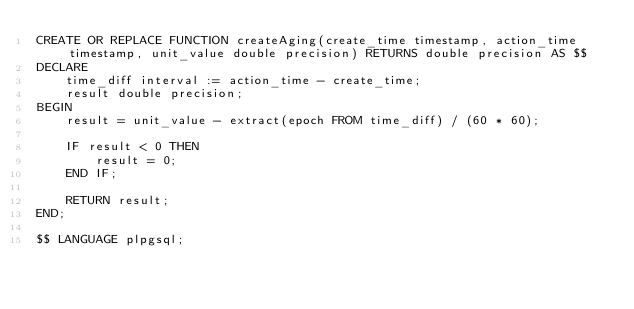Convert code to text. <code><loc_0><loc_0><loc_500><loc_500><_SQL_>CREATE OR REPLACE FUNCTION createAging(create_time timestamp, action_time timestamp, unit_value double precision) RETURNS double precision AS $$
DECLARE
    time_diff interval := action_time - create_time;
    result double precision;
BEGIN
    result = unit_value - extract(epoch FROM time_diff) / (60 * 60);
    
    IF result < 0 THEN
        result = 0;
    END IF;
    
    RETURN result;
END;

$$ LANGUAGE plpgsql;</code> 